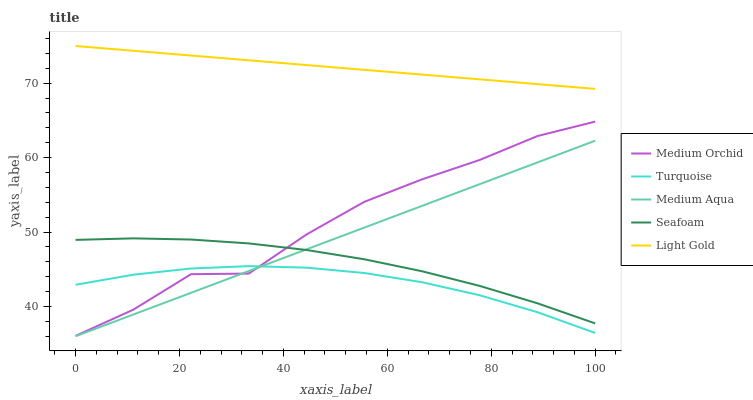Does Turquoise have the minimum area under the curve?
Answer yes or no. Yes. Does Light Gold have the maximum area under the curve?
Answer yes or no. Yes. Does Medium Orchid have the minimum area under the curve?
Answer yes or no. No. Does Medium Orchid have the maximum area under the curve?
Answer yes or no. No. Is Light Gold the smoothest?
Answer yes or no. Yes. Is Medium Orchid the roughest?
Answer yes or no. Yes. Is Turquoise the smoothest?
Answer yes or no. No. Is Turquoise the roughest?
Answer yes or no. No. Does Medium Aqua have the lowest value?
Answer yes or no. Yes. Does Turquoise have the lowest value?
Answer yes or no. No. Does Light Gold have the highest value?
Answer yes or no. Yes. Does Medium Orchid have the highest value?
Answer yes or no. No. Is Turquoise less than Seafoam?
Answer yes or no. Yes. Is Light Gold greater than Turquoise?
Answer yes or no. Yes. Does Medium Orchid intersect Turquoise?
Answer yes or no. Yes. Is Medium Orchid less than Turquoise?
Answer yes or no. No. Is Medium Orchid greater than Turquoise?
Answer yes or no. No. Does Turquoise intersect Seafoam?
Answer yes or no. No. 